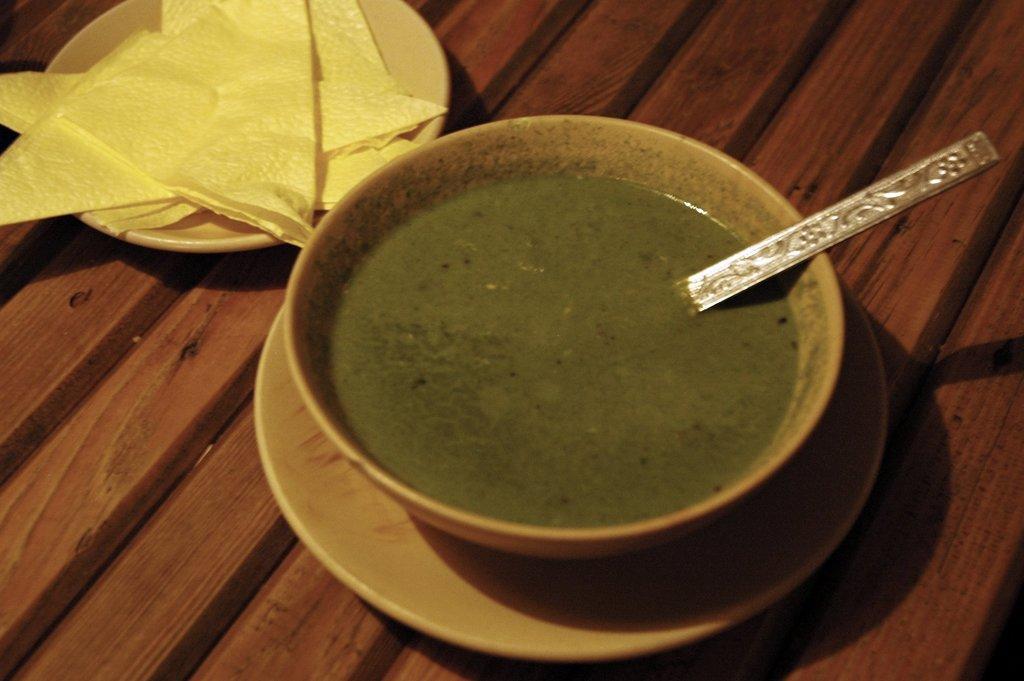In one or two sentences, can you explain what this image depicts? In this image, we can see a bowl with food item and a spoon on the surface. We can also see a plate with tissues on the surface. 